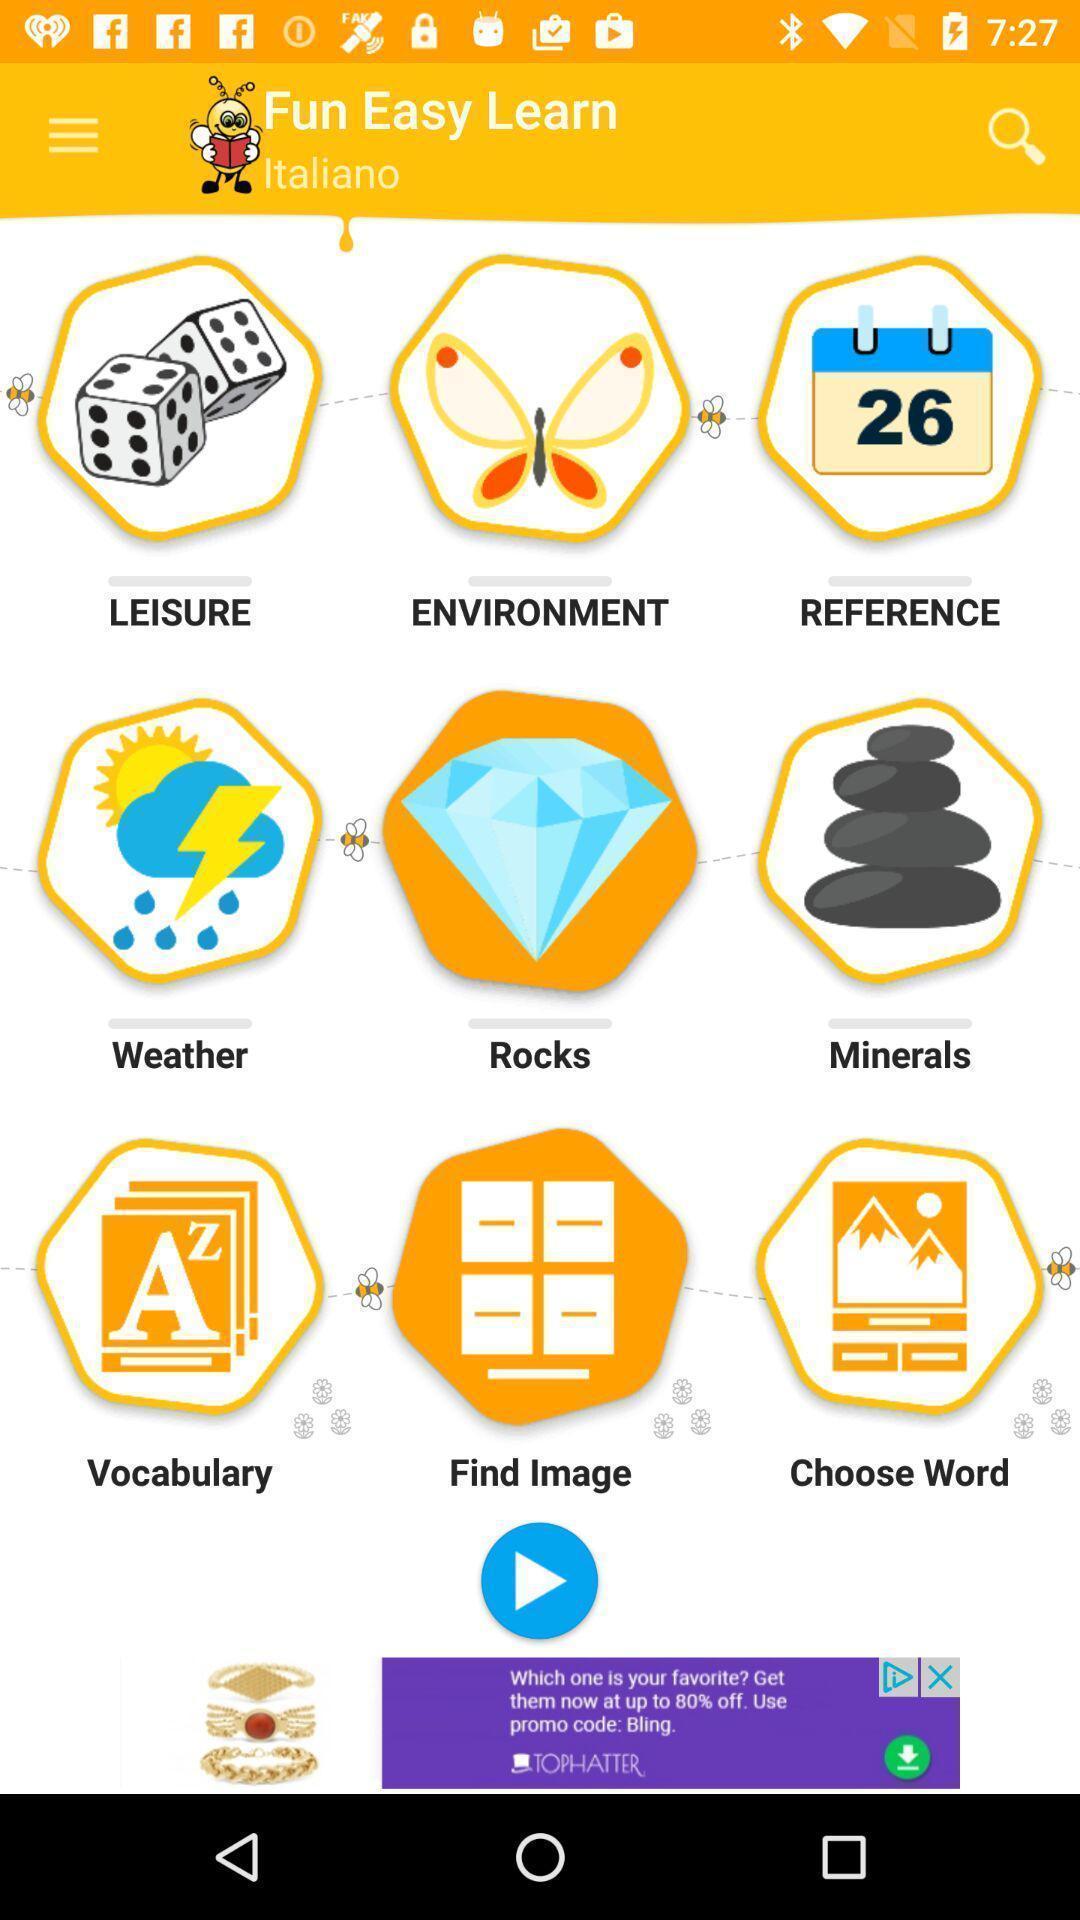Describe this image in words. Page showing various categories in learning application. 